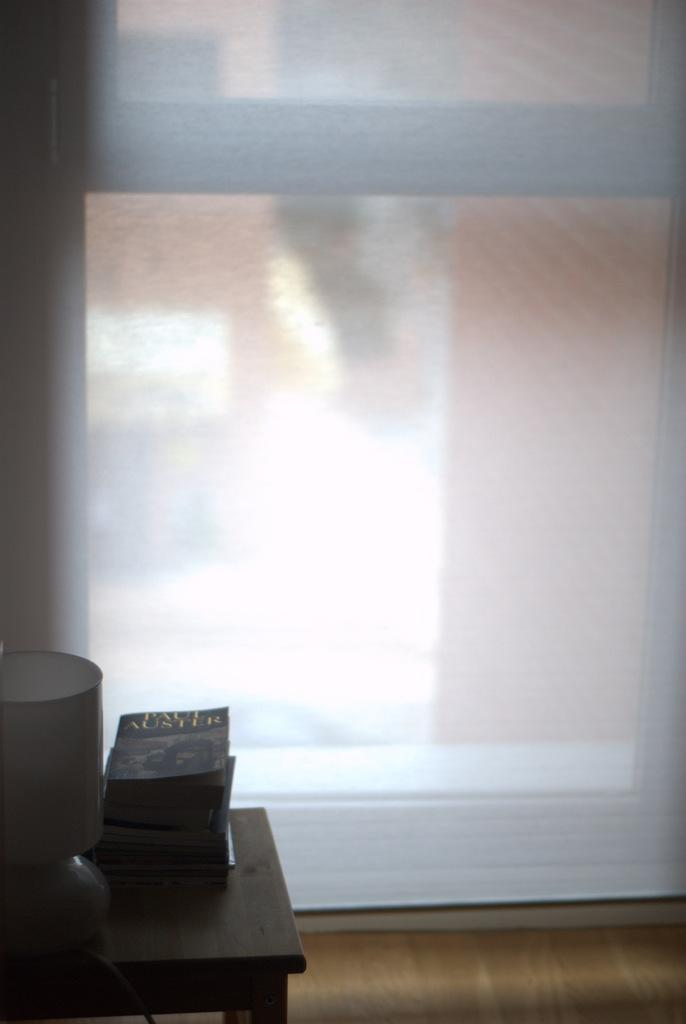What is located in the left bottom of the picture? There is a table in the left bottom of the picture. What items can be seen on the table? Books and a lamp are placed on the table. What is the color of the door visible in the image? The door is white. Where was the image taken? The image was taken inside a room. How many pizzas are being delivered by the authority figure in the image? There are no pizzas or authority figures present in the image. What type of net is being used to catch the fish in the image? There are no nets or fish present in the image. 